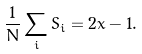<formula> <loc_0><loc_0><loc_500><loc_500>\frac { 1 } { N } \sum _ { i } S _ { i } = 2 x - 1 .</formula> 